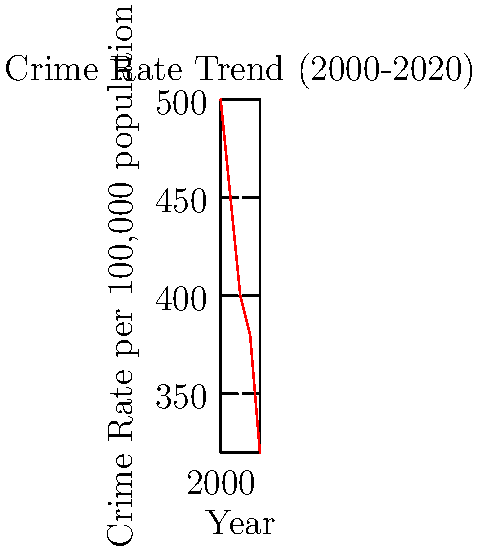Based on the line graph showing crime rates from 2000 to 2020, what sociological theory might best explain the observed trend, and how could this information be used to inform crime prevention strategies? To answer this question, let's analyze the graph and apply sociological theories:

1. Observe the trend: The graph shows a consistent decline in crime rates from 2000 to 2020.

2. Consider sociological theories:
   a) Social Disorganization Theory: Focuses on community-level factors.
   b) Strain Theory: Emphasizes societal pressures and inequality.
   c) Social Control Theory: Examines bonds to society and institutions.
   d) Routine Activity Theory: Looks at daily patterns and opportunities for crime.

3. Best fitting theory: Social Control Theory appears most relevant.
   - The declining trend suggests strengthening social bonds over time.
   - Improved community engagement and institutional effectiveness may explain the decrease.

4. Application to crime prevention:
   - Strengthen social institutions (family, schools, community organizations).
   - Promote community engagement and social cohesion.
   - Implement programs that increase attachment to conventional norms.
   - Focus on early intervention and youth development programs.

5. Policy implications:
   - Invest in education and after-school programs.
   - Support family counseling and parenting classes.
   - Encourage neighborhood watch programs and community policing.
   - Develop job training and employment opportunities.

By applying Social Control Theory to interpret the declining crime rates and inform prevention strategies, policymakers can focus on reinforcing social bonds and institutional effectiveness to continue the positive trend.
Answer: Social Control Theory; strengthen social bonds and institutions 